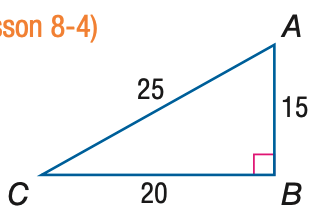Answer the mathemtical geometry problem and directly provide the correct option letter.
Question: Express the ratio of \tan C as a decimal to the nearest hundredth.
Choices: A: 0.60 B: 0.75 C: 0.80 D: 1.33 B 